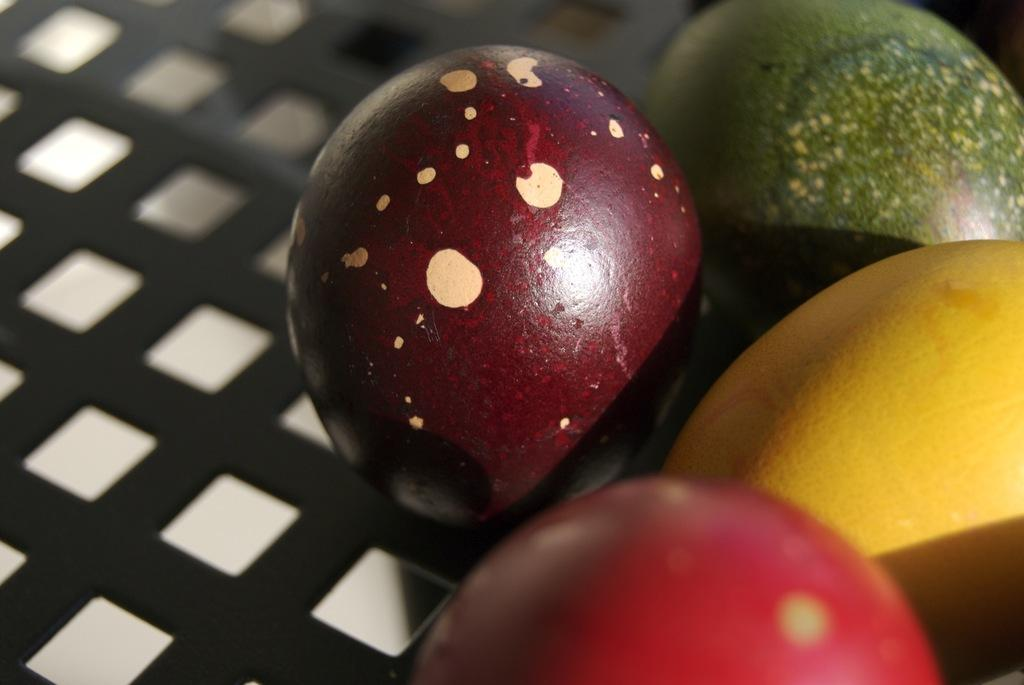What is the primary surface or structure in the image? There are objects on a mesh in the image. Can you describe the mesh in more detail? Unfortunately, the facts provided do not give any additional details about the mesh. What types of objects are on the mesh? The facts provided do not specify the types of objects on the mesh. What is the reason for the ongoing battle in the image? There is no mention of a battle or any conflict in the image, so it is not possible to determine the reason for one. 